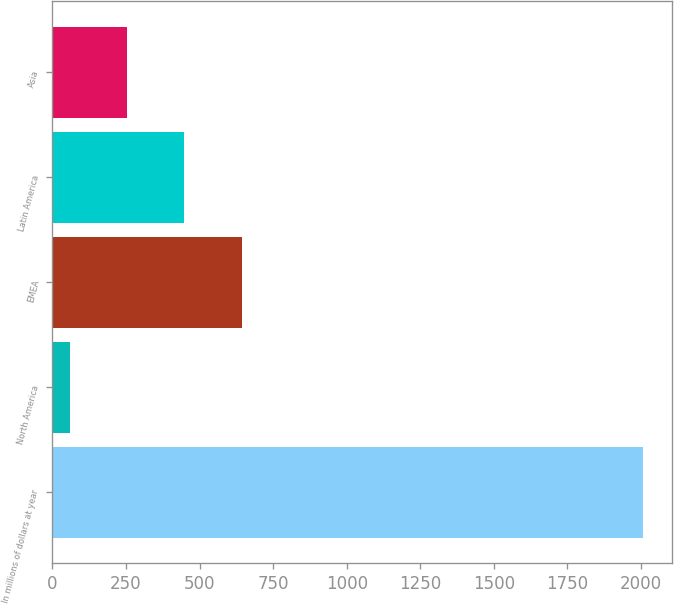<chart> <loc_0><loc_0><loc_500><loc_500><bar_chart><fcel>In millions of dollars at year<fcel>North America<fcel>EMEA<fcel>Latin America<fcel>Asia<nl><fcel>2006<fcel>59<fcel>643.1<fcel>448.4<fcel>253.7<nl></chart> 